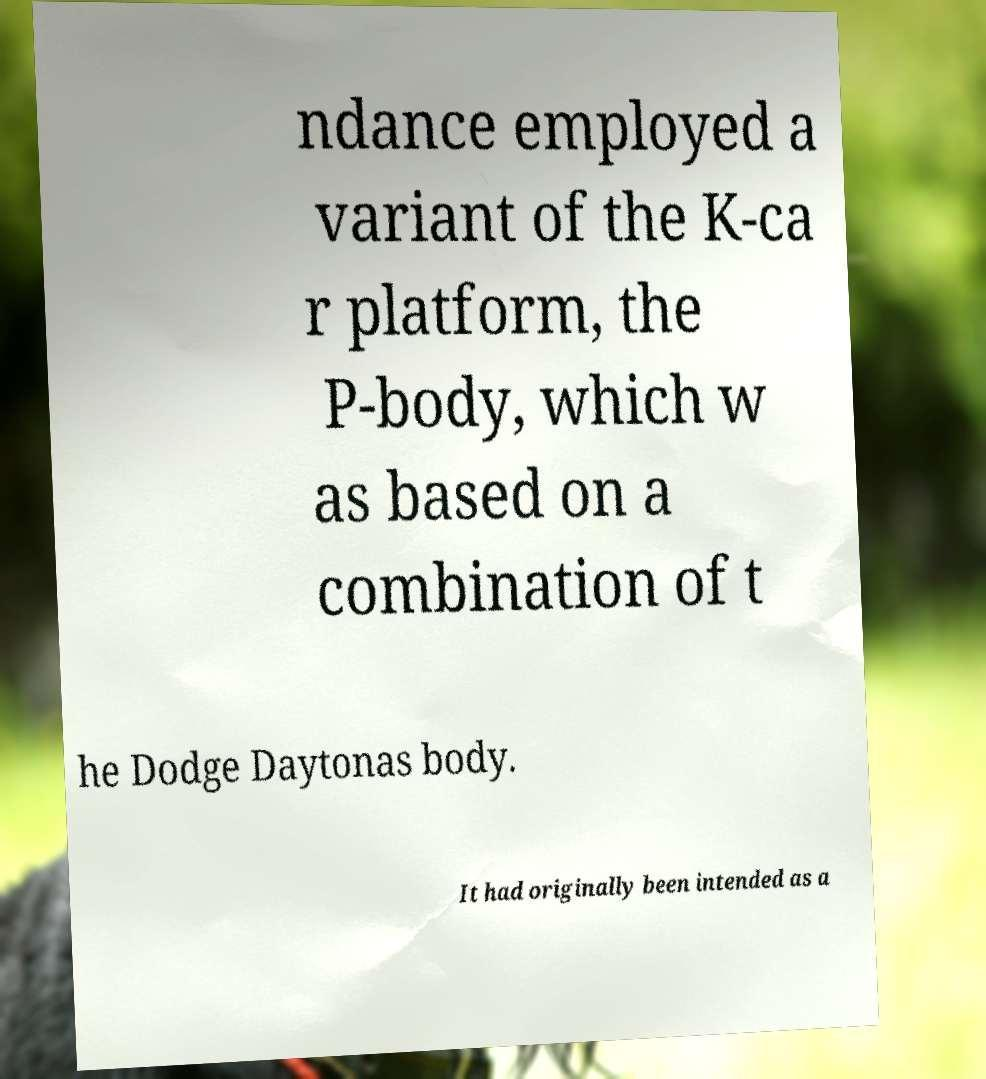Please read and relay the text visible in this image. What does it say? ndance employed a variant of the K-ca r platform, the P-body, which w as based on a combination of t he Dodge Daytonas body. It had originally been intended as a 